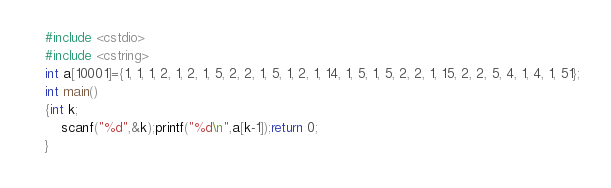<code> <loc_0><loc_0><loc_500><loc_500><_C++_>#include <cstdio>
#include <cstring>
int a[10001]={1, 1, 1, 2, 1, 2, 1, 5, 2, 2, 1, 5, 1, 2, 1, 14, 1, 5, 1, 5, 2, 2, 1, 15, 2, 2, 5, 4, 1, 4, 1, 51};
int main()
{int k;
	scanf("%d",&k);printf("%d\n",a[k-1]);return 0;
}</code> 